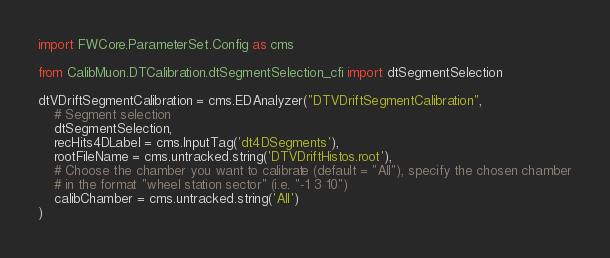<code> <loc_0><loc_0><loc_500><loc_500><_Python_>import FWCore.ParameterSet.Config as cms

from CalibMuon.DTCalibration.dtSegmentSelection_cfi import dtSegmentSelection

dtVDriftSegmentCalibration = cms.EDAnalyzer("DTVDriftSegmentCalibration",
    # Segment selection
    dtSegmentSelection,
    recHits4DLabel = cms.InputTag('dt4DSegments'),
    rootFileName = cms.untracked.string('DTVDriftHistos.root'),
    # Choose the chamber you want to calibrate (default = "All"), specify the chosen chamber
    # in the format "wheel station sector" (i.e. "-1 3 10")
    calibChamber = cms.untracked.string('All')
)
</code> 